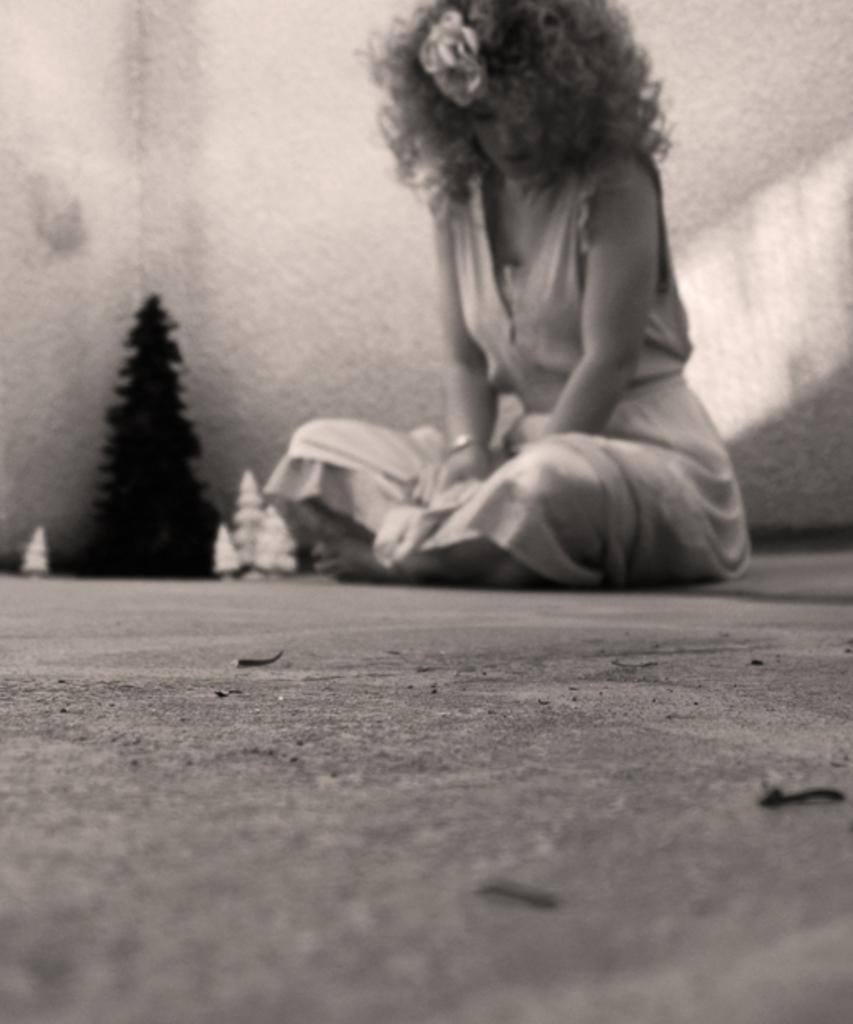What is the woman in the image doing? The woman is sitting on the floor in the image. What can be seen in the background of the image? A wall is visible in the background of the image. What is the main decoration in the image? There is a Christmas tree in the image. What are the white objects on the floor? The white objects on the floor are not specified in the facts, but they are present in the image. What type of addition problem is the woman solving with her toothbrush in the image? There is no toothbrush or addition problem present in the image. 